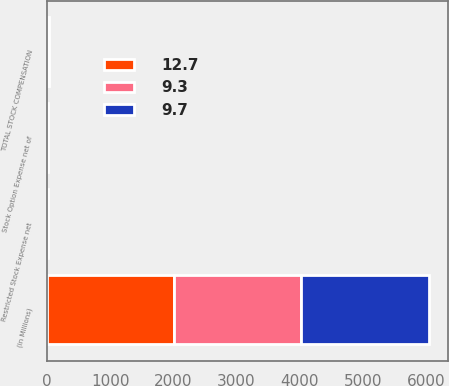Convert chart. <chart><loc_0><loc_0><loc_500><loc_500><stacked_bar_chart><ecel><fcel>(in Millions)<fcel>Stock Option Expense net of<fcel>Restricted Stock Expense net<fcel>TOTAL STOCK COMPENSATION<nl><fcel>9.7<fcel>2016<fcel>4.4<fcel>6.5<fcel>12.7<nl><fcel>12.7<fcel>2015<fcel>4.1<fcel>5.1<fcel>9.7<nl><fcel>9.3<fcel>2014<fcel>3.8<fcel>5.5<fcel>9.3<nl></chart> 